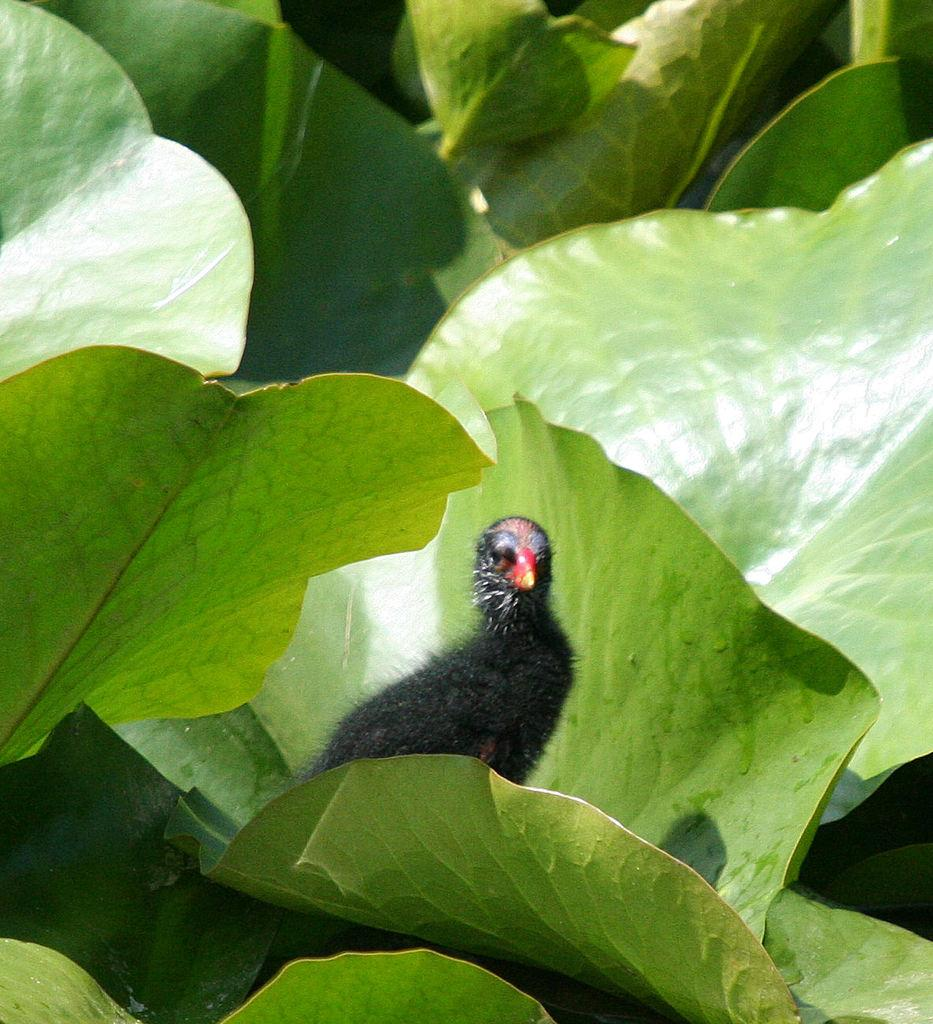What type of animal is present in the image? There is a bird in the image. Where is the bird located? The bird is on a tree. What can be observed about the tree in the image? The tree has leaves. Can you see any apples on the tree in the image? There are no apples visible on the tree in the image. Is there a giraffe standing next to the tree in the image? There is no giraffe present in the image. 